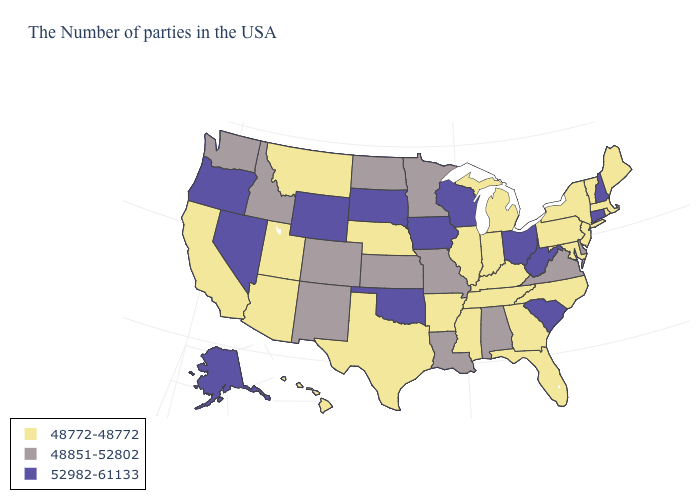Name the states that have a value in the range 52982-61133?
Concise answer only. New Hampshire, Connecticut, South Carolina, West Virginia, Ohio, Wisconsin, Iowa, Oklahoma, South Dakota, Wyoming, Nevada, Oregon, Alaska. Does New Hampshire have the highest value in the USA?
Answer briefly. Yes. What is the value of Vermont?
Concise answer only. 48772-48772. Name the states that have a value in the range 48772-48772?
Write a very short answer. Maine, Massachusetts, Rhode Island, Vermont, New York, New Jersey, Maryland, Pennsylvania, North Carolina, Florida, Georgia, Michigan, Kentucky, Indiana, Tennessee, Illinois, Mississippi, Arkansas, Nebraska, Texas, Utah, Montana, Arizona, California, Hawaii. What is the lowest value in states that border Maryland?
Keep it brief. 48772-48772. What is the value of Ohio?
Answer briefly. 52982-61133. What is the value of Florida?
Be succinct. 48772-48772. Name the states that have a value in the range 52982-61133?
Answer briefly. New Hampshire, Connecticut, South Carolina, West Virginia, Ohio, Wisconsin, Iowa, Oklahoma, South Dakota, Wyoming, Nevada, Oregon, Alaska. What is the value of Connecticut?
Keep it brief. 52982-61133. What is the value of Arizona?
Answer briefly. 48772-48772. What is the lowest value in the USA?
Short answer required. 48772-48772. Among the states that border Texas , which have the lowest value?
Keep it brief. Arkansas. Does West Virginia have a higher value than Washington?
Give a very brief answer. Yes. What is the lowest value in the Northeast?
Keep it brief. 48772-48772. Does South Dakota have the same value as Oklahoma?
Be succinct. Yes. 